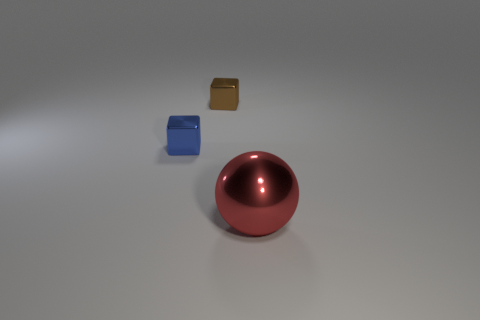There is a small cube left of the block behind the small object left of the tiny brown thing; what is it made of?
Offer a terse response. Metal. There is a object that is behind the tiny blue metallic cube; what shape is it?
Your response must be concise. Cube. The brown thing that is made of the same material as the tiny blue cube is what size?
Provide a short and direct response. Small. What number of rubber things are the same shape as the tiny brown metal object?
Your answer should be compact. 0. Do the shiny cube behind the tiny blue metallic thing and the big shiny ball have the same color?
Provide a succinct answer. No. There is a metal thing on the right side of the tiny object right of the blue cube; how many big metal objects are on the left side of it?
Make the answer very short. 0. How many metallic objects are left of the big thing and to the right of the tiny blue metal block?
Provide a short and direct response. 1. Is there anything else that is the same material as the big red sphere?
Make the answer very short. Yes. Do the small brown thing and the big thing have the same material?
Offer a terse response. Yes. The small metallic thing on the left side of the metal cube behind the tiny metallic thing that is in front of the small brown shiny block is what shape?
Make the answer very short. Cube. 